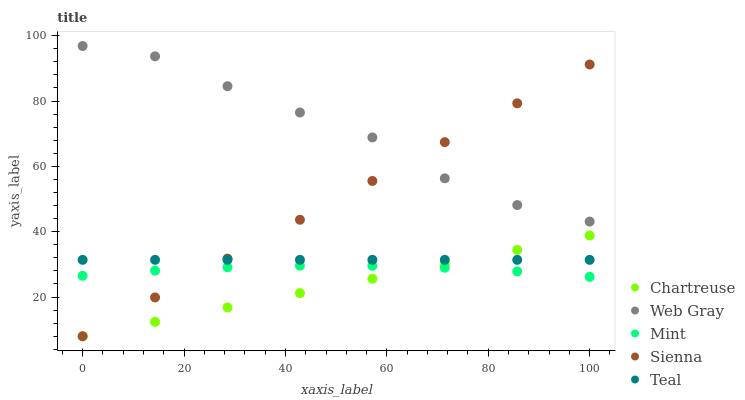Does Chartreuse have the minimum area under the curve?
Answer yes or no. Yes. Does Web Gray have the maximum area under the curve?
Answer yes or no. Yes. Does Web Gray have the minimum area under the curve?
Answer yes or no. No. Does Chartreuse have the maximum area under the curve?
Answer yes or no. No. Is Chartreuse the smoothest?
Answer yes or no. Yes. Is Web Gray the roughest?
Answer yes or no. Yes. Is Web Gray the smoothest?
Answer yes or no. No. Is Chartreuse the roughest?
Answer yes or no. No. Does Sienna have the lowest value?
Answer yes or no. Yes. Does Web Gray have the lowest value?
Answer yes or no. No. Does Web Gray have the highest value?
Answer yes or no. Yes. Does Chartreuse have the highest value?
Answer yes or no. No. Is Chartreuse less than Web Gray?
Answer yes or no. Yes. Is Teal greater than Mint?
Answer yes or no. Yes. Does Sienna intersect Chartreuse?
Answer yes or no. Yes. Is Sienna less than Chartreuse?
Answer yes or no. No. Is Sienna greater than Chartreuse?
Answer yes or no. No. Does Chartreuse intersect Web Gray?
Answer yes or no. No. 